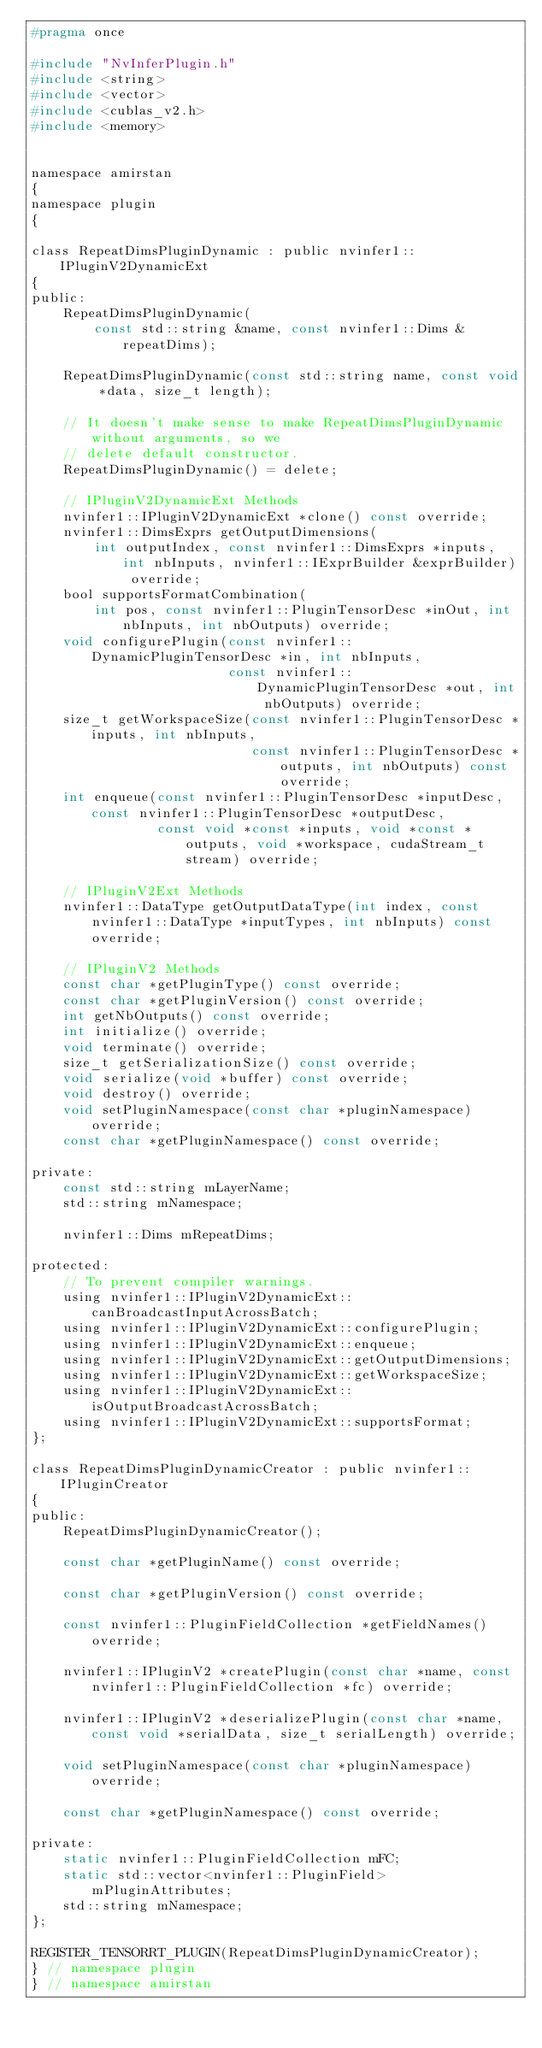Convert code to text. <code><loc_0><loc_0><loc_500><loc_500><_C_>#pragma once

#include "NvInferPlugin.h"
#include <string>
#include <vector>
#include <cublas_v2.h>
#include <memory>


namespace amirstan
{
namespace plugin
{

class RepeatDimsPluginDynamic : public nvinfer1::IPluginV2DynamicExt
{
public:
    RepeatDimsPluginDynamic(
        const std::string &name, const nvinfer1::Dims &repeatDims);

    RepeatDimsPluginDynamic(const std::string name, const void *data, size_t length);

    // It doesn't make sense to make RepeatDimsPluginDynamic without arguments, so we
    // delete default constructor.
    RepeatDimsPluginDynamic() = delete;

    // IPluginV2DynamicExt Methods
    nvinfer1::IPluginV2DynamicExt *clone() const override;
    nvinfer1::DimsExprs getOutputDimensions(
        int outputIndex, const nvinfer1::DimsExprs *inputs, int nbInputs, nvinfer1::IExprBuilder &exprBuilder) override;
    bool supportsFormatCombination(
        int pos, const nvinfer1::PluginTensorDesc *inOut, int nbInputs, int nbOutputs) override;
    void configurePlugin(const nvinfer1::DynamicPluginTensorDesc *in, int nbInputs,
                         const nvinfer1::DynamicPluginTensorDesc *out, int nbOutputs) override;
    size_t getWorkspaceSize(const nvinfer1::PluginTensorDesc *inputs, int nbInputs,
                            const nvinfer1::PluginTensorDesc *outputs, int nbOutputs) const override;
    int enqueue(const nvinfer1::PluginTensorDesc *inputDesc, const nvinfer1::PluginTensorDesc *outputDesc,
                const void *const *inputs, void *const *outputs, void *workspace, cudaStream_t stream) override;

    // IPluginV2Ext Methods
    nvinfer1::DataType getOutputDataType(int index, const nvinfer1::DataType *inputTypes, int nbInputs) const override;

    // IPluginV2 Methods
    const char *getPluginType() const override;
    const char *getPluginVersion() const override;
    int getNbOutputs() const override;
    int initialize() override;
    void terminate() override;
    size_t getSerializationSize() const override;
    void serialize(void *buffer) const override;
    void destroy() override;
    void setPluginNamespace(const char *pluginNamespace) override;
    const char *getPluginNamespace() const override;

private:
    const std::string mLayerName;
    std::string mNamespace;

    nvinfer1::Dims mRepeatDims;

protected:
    // To prevent compiler warnings.
    using nvinfer1::IPluginV2DynamicExt::canBroadcastInputAcrossBatch;
    using nvinfer1::IPluginV2DynamicExt::configurePlugin;
    using nvinfer1::IPluginV2DynamicExt::enqueue;
    using nvinfer1::IPluginV2DynamicExt::getOutputDimensions;
    using nvinfer1::IPluginV2DynamicExt::getWorkspaceSize;
    using nvinfer1::IPluginV2DynamicExt::isOutputBroadcastAcrossBatch;
    using nvinfer1::IPluginV2DynamicExt::supportsFormat;
};

class RepeatDimsPluginDynamicCreator : public nvinfer1::IPluginCreator
{
public:
    RepeatDimsPluginDynamicCreator();

    const char *getPluginName() const override;

    const char *getPluginVersion() const override;

    const nvinfer1::PluginFieldCollection *getFieldNames() override;

    nvinfer1::IPluginV2 *createPlugin(const char *name, const nvinfer1::PluginFieldCollection *fc) override;

    nvinfer1::IPluginV2 *deserializePlugin(const char *name, const void *serialData, size_t serialLength) override;

    void setPluginNamespace(const char *pluginNamespace) override;

    const char *getPluginNamespace() const override;

private:
    static nvinfer1::PluginFieldCollection mFC;
    static std::vector<nvinfer1::PluginField> mPluginAttributes;
    std::string mNamespace;
};

REGISTER_TENSORRT_PLUGIN(RepeatDimsPluginDynamicCreator);
} // namespace plugin
} // namespace amirstan</code> 